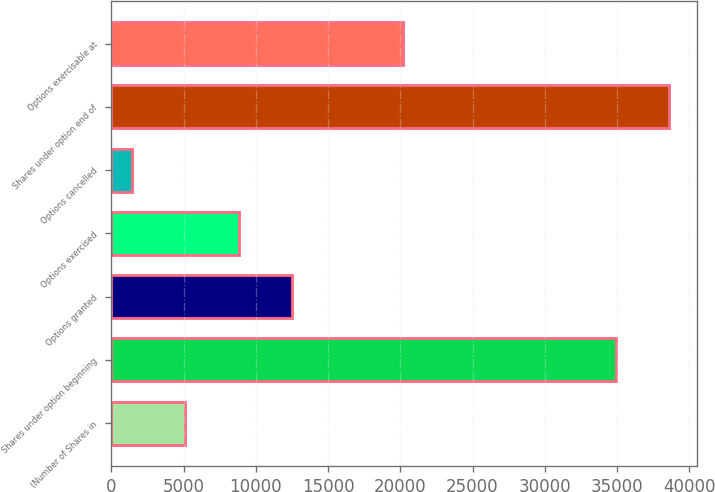<chart> <loc_0><loc_0><loc_500><loc_500><bar_chart><fcel>(Number of Shares in<fcel>Shares under option beginning<fcel>Options granted<fcel>Options exercised<fcel>Options cancelled<fcel>Shares under option end of<fcel>Options exercisable at<nl><fcel>5131.9<fcel>34939<fcel>12505.7<fcel>8818.8<fcel>1445<fcel>38625.9<fcel>20166<nl></chart> 